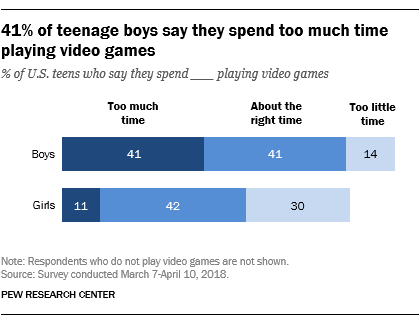Indicate a few pertinent items in this graphic. According to the data, 41% of boys are choosing to spend too much time on their devices. Girls and boys who choose to spend too little time on a task often have significant differences in their approach and outcomes. 